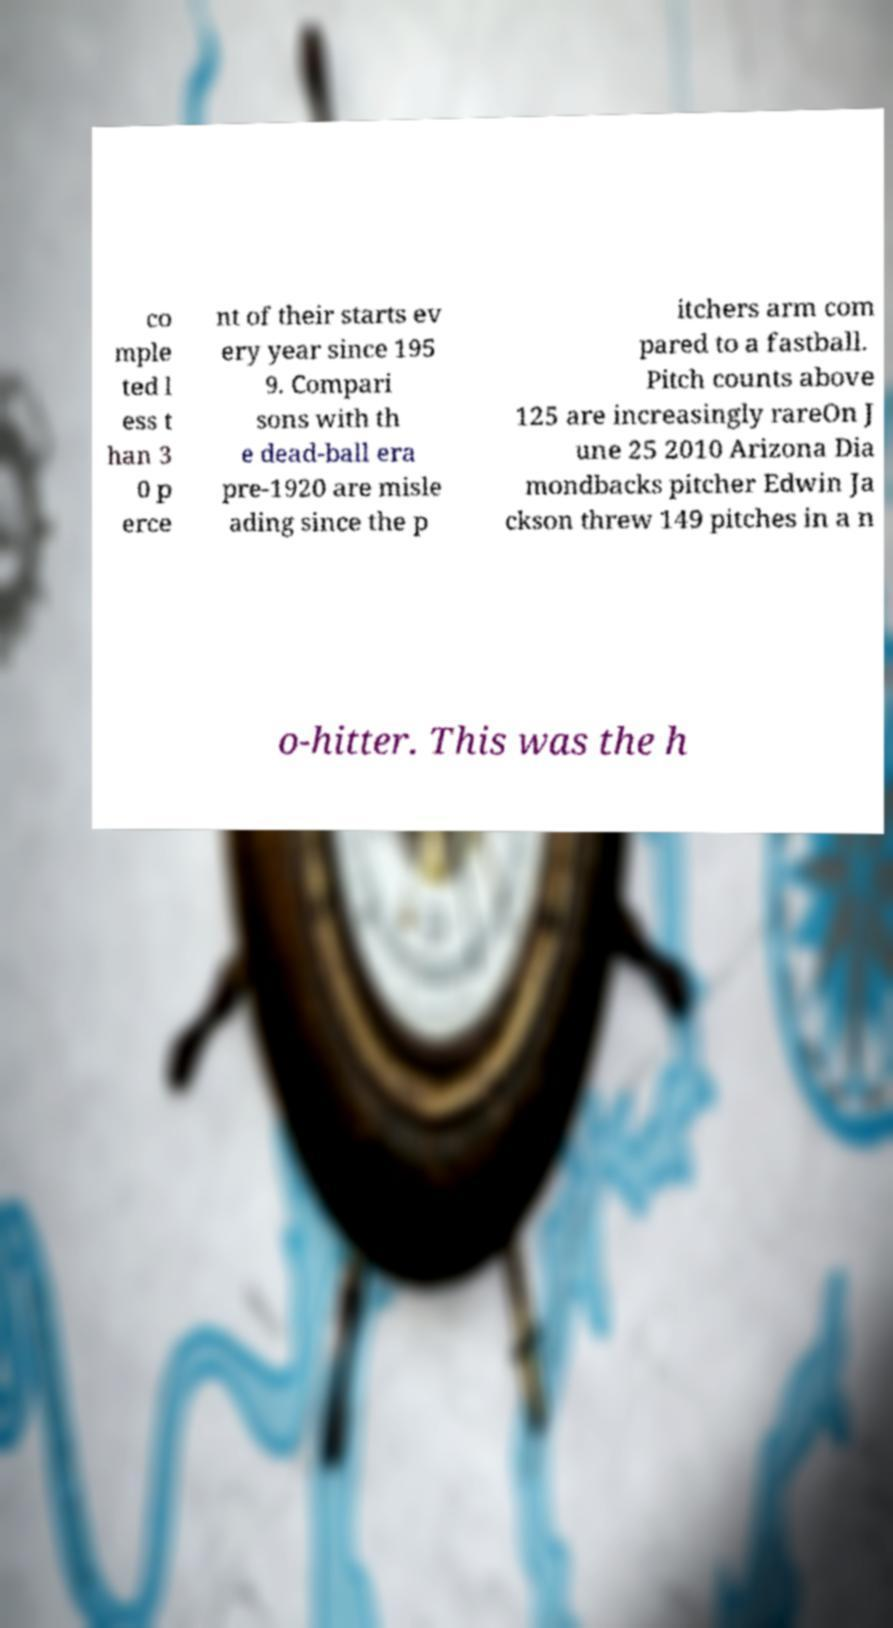What messages or text are displayed in this image? I need them in a readable, typed format. co mple ted l ess t han 3 0 p erce nt of their starts ev ery year since 195 9. Compari sons with th e dead-ball era pre-1920 are misle ading since the p itchers arm com pared to a fastball. Pitch counts above 125 are increasingly rareOn J une 25 2010 Arizona Dia mondbacks pitcher Edwin Ja ckson threw 149 pitches in a n o-hitter. This was the h 